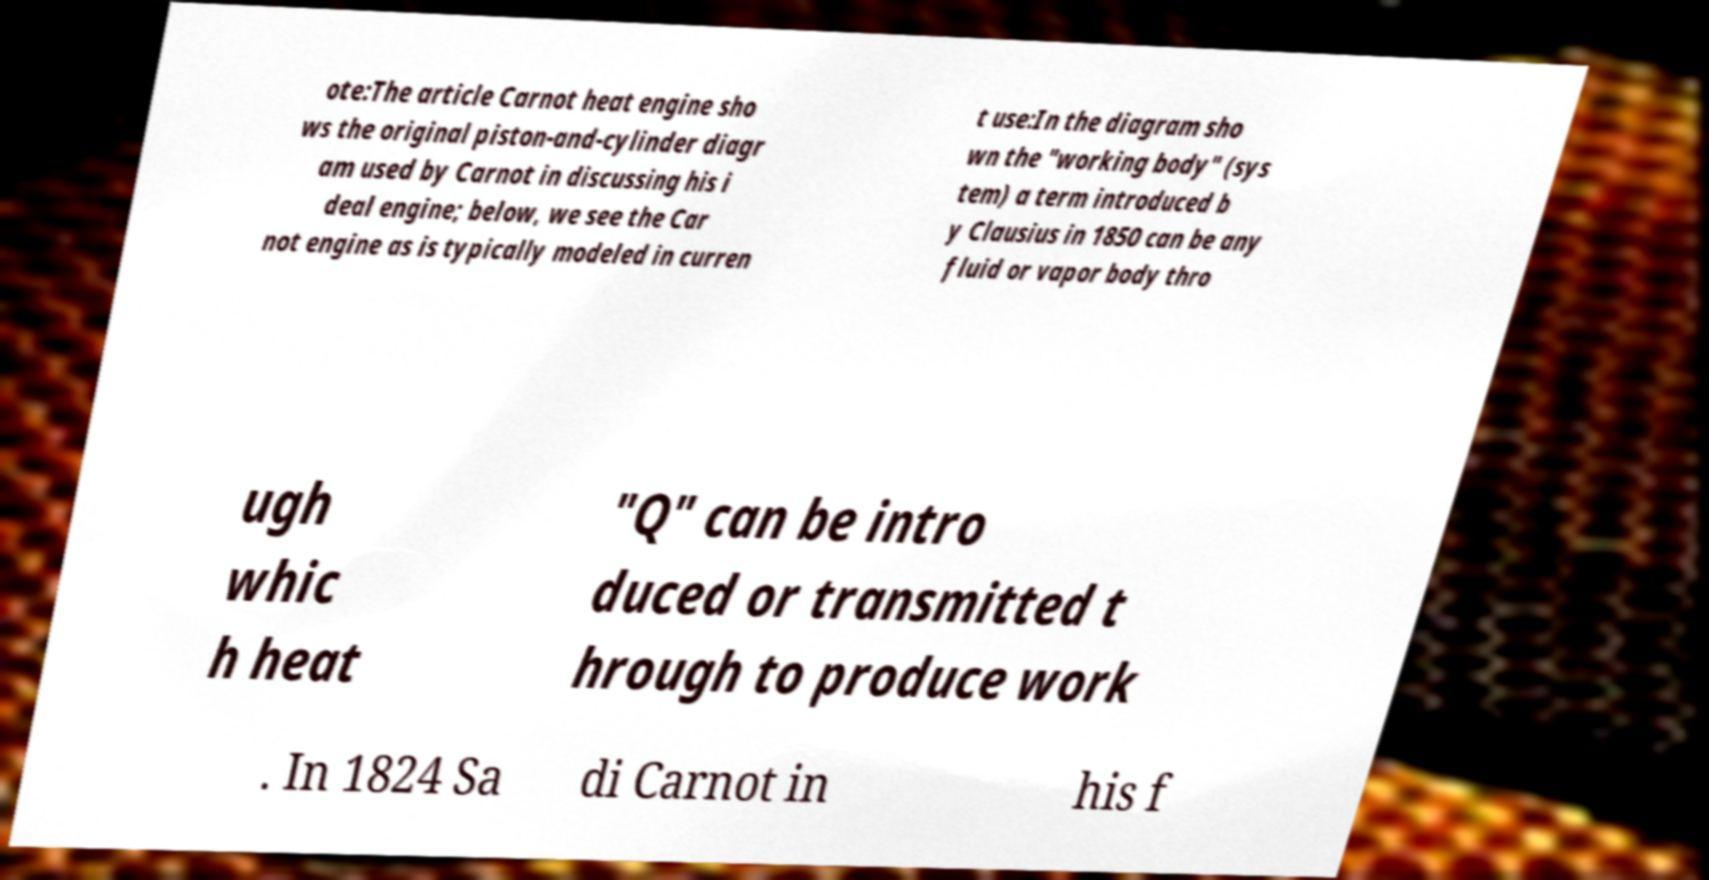For documentation purposes, I need the text within this image transcribed. Could you provide that? ote:The article Carnot heat engine sho ws the original piston-and-cylinder diagr am used by Carnot in discussing his i deal engine; below, we see the Car not engine as is typically modeled in curren t use:In the diagram sho wn the "working body" (sys tem) a term introduced b y Clausius in 1850 can be any fluid or vapor body thro ugh whic h heat "Q" can be intro duced or transmitted t hrough to produce work . In 1824 Sa di Carnot in his f 